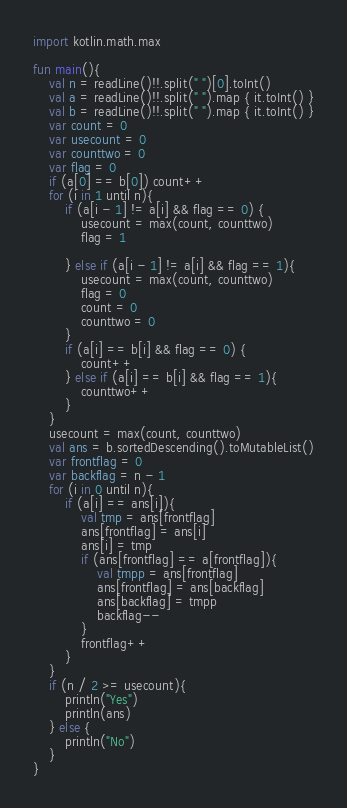Convert code to text. <code><loc_0><loc_0><loc_500><loc_500><_Kotlin_>import kotlin.math.max

fun main(){
    val n = readLine()!!.split(" ")[0].toInt()
    val a = readLine()!!.split(" ").map { it.toInt() }
    val b = readLine()!!.split(" ").map { it.toInt() }
    var count = 0
    var usecount = 0
    var counttwo = 0
    var flag = 0
    if (a[0] == b[0]) count++
    for (i in 1 until n){
        if (a[i - 1] != a[i] && flag == 0) {
            usecount = max(count, counttwo)
            flag = 1

        } else if (a[i - 1] != a[i] && flag == 1){
            usecount = max(count, counttwo)
            flag = 0
            count = 0
            counttwo = 0
        }
        if (a[i] == b[i] && flag == 0) {
            count++
        } else if (a[i] == b[i] && flag == 1){
            counttwo++
        }
    }
    usecount = max(count, counttwo)
    val ans = b.sortedDescending().toMutableList()
    var frontflag = 0
    var backflag = n - 1
    for (i in 0 until n){
        if (a[i] == ans[i]){
            val tmp = ans[frontflag]
            ans[frontflag] = ans[i]
            ans[i] = tmp
            if (ans[frontflag] == a[frontflag]){
                val tmpp = ans[frontflag]
                ans[frontflag] = ans[backflag]
                ans[backflag] = tmpp
                backflag--
            }
            frontflag++
        }
    }
    if (n / 2 >= usecount){
        println("Yes")
        println(ans)
    } else {
        println("No")
    }
}</code> 